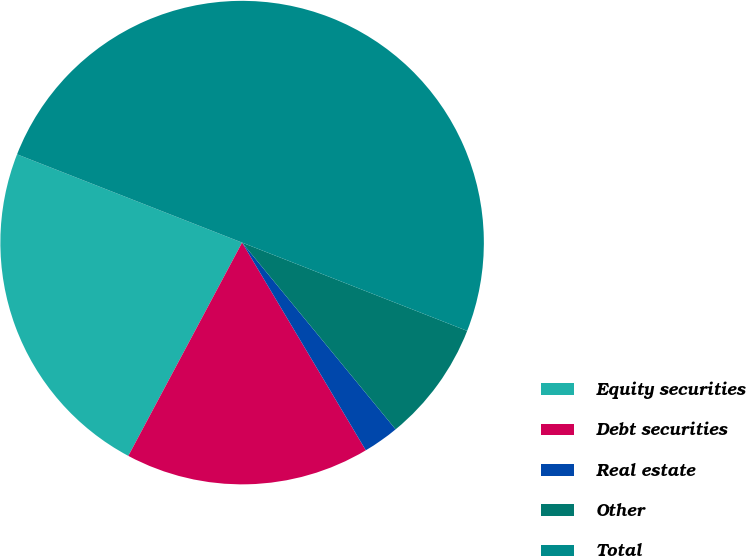<chart> <loc_0><loc_0><loc_500><loc_500><pie_chart><fcel>Equity securities<fcel>Debt securities<fcel>Real estate<fcel>Other<fcel>Total<nl><fcel>23.15%<fcel>16.35%<fcel>2.4%<fcel>8.1%<fcel>50.0%<nl></chart> 